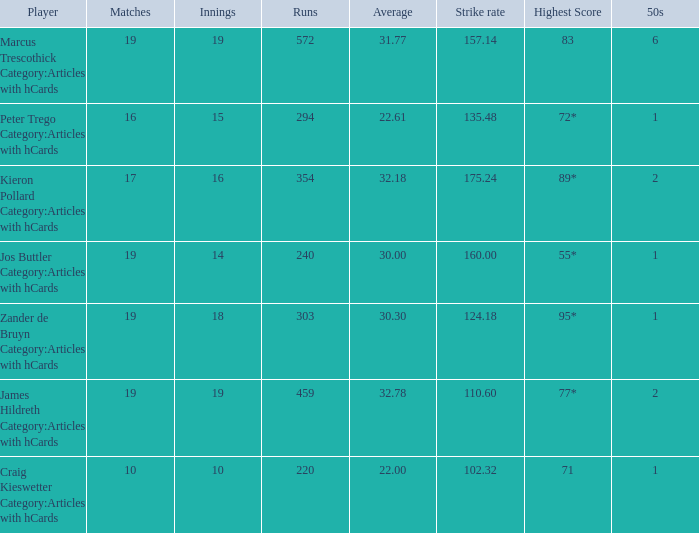What is the top score for the player with a mean of 3 55*. 